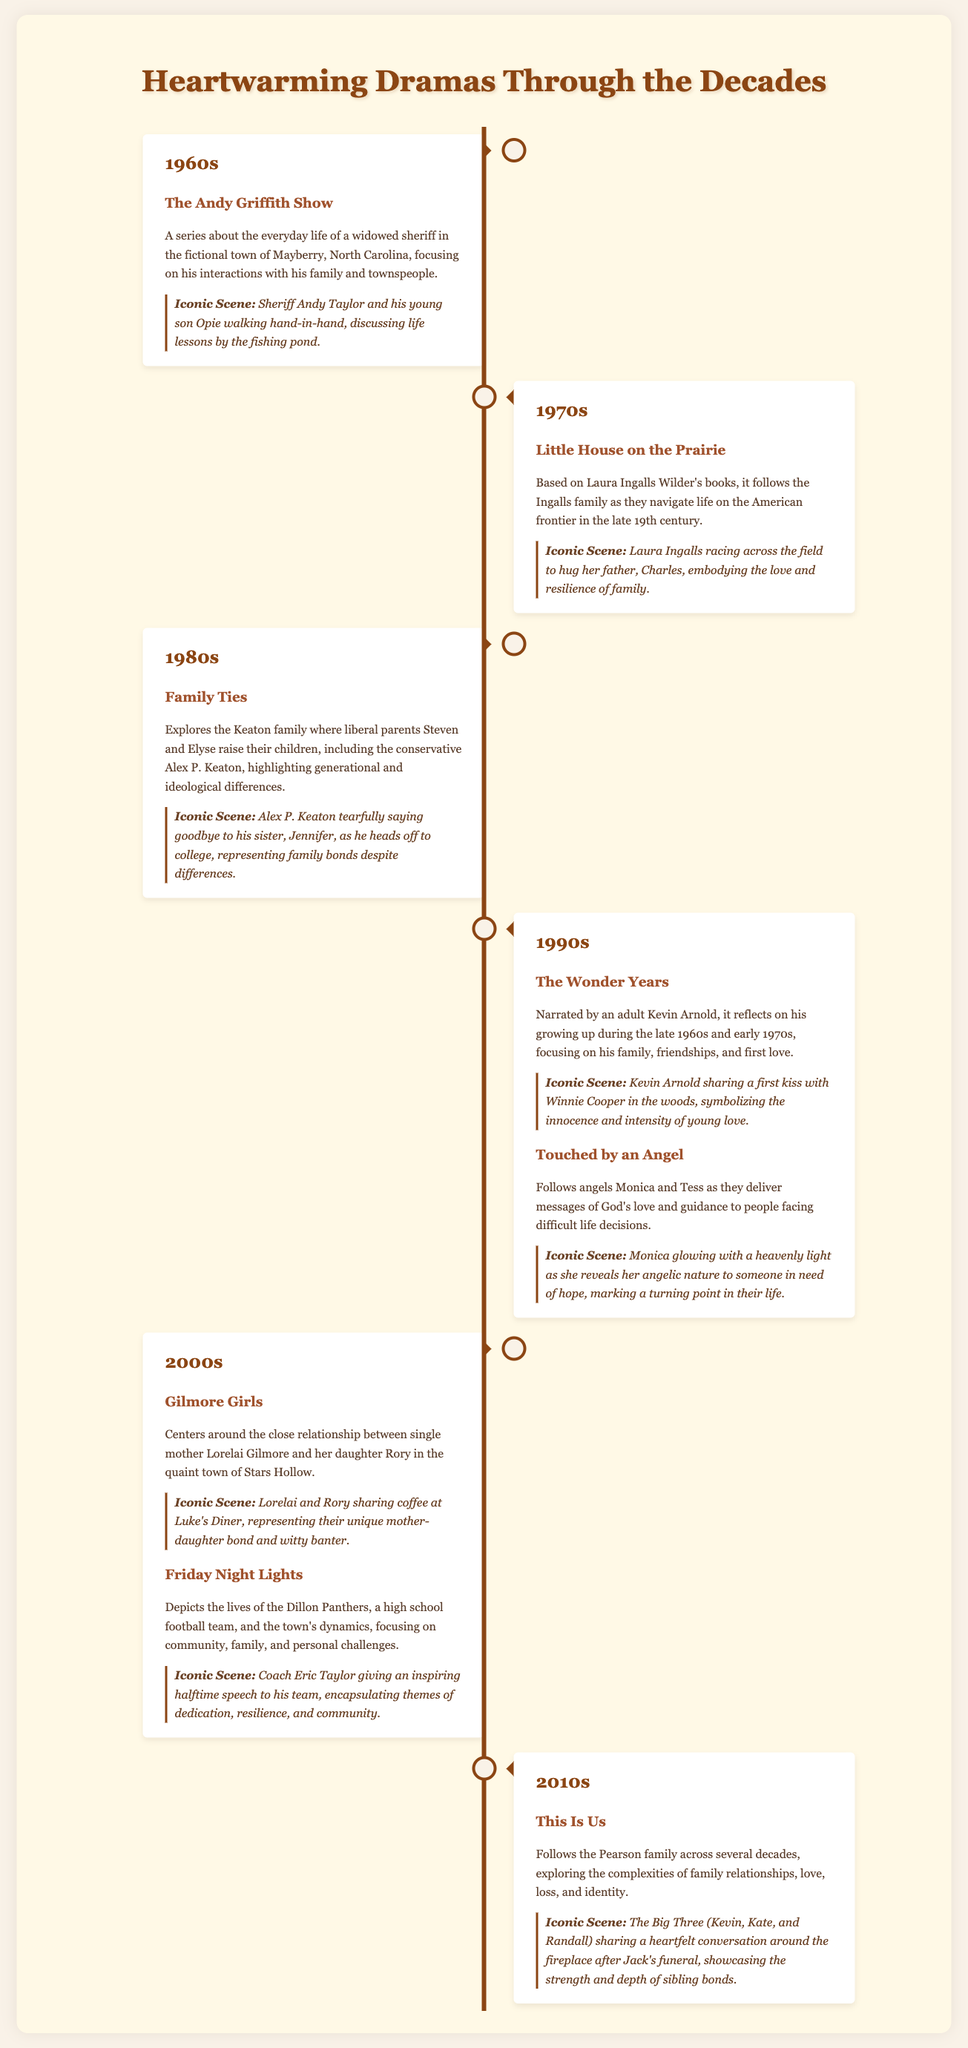What was the first heartwarming drama featured in the infographic? The first heartwarming drama mentioned is "The Andy Griffith Show," which aired in the 1960s.
Answer: The Andy Griffith Show In which decade did "Little House on the Prairie" air? "Little House on the Prairie" is listed under the 1970s section of the infographic.
Answer: 1970s What is the iconic scene from "The Wonder Years"? The iconic scene described from "The Wonder Years" is Kevin Arnold sharing a first kiss with Winnie Cooper in the woods.
Answer: Kevin Arnold sharing a first kiss with Winnie Cooper How many shows are highlighted from the 1990s? Two shows are highlighted from the 1990s: "The Wonder Years" and "Touched by an Angel."
Answer: Two Which show features a single mother and her daughter in a quaint town? "Gilmore Girls" centers around the relationship of a single mother and her daughter in Stars Hollow.
Answer: Gilmore Girls What theme is reflected in "Friday Night Lights"? The theme of community, family, and personal challenges is reflected in "Friday Night Lights."
Answer: Community, family, and personal challenges Which iconic scene represents the strong sibling bond in "This Is Us"? The scene highlighting the strong sibling bond is The Big Three sharing a heartfelt conversation around the fireplace after Jack's funeral.
Answer: The Big Three sharing a heartfelt conversation In which section is "Family Ties" located? "Family Ties" is highlighted in the 1980s section of the infographic.
Answer: 1980s What character is associated with the conservative viewpoint in "Family Ties"? Alex P. Keaton is the character associated with the conservative viewpoint in "Family Ties."
Answer: Alex P. Keaton 